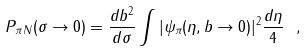<formula> <loc_0><loc_0><loc_500><loc_500>P _ { \pi N } ( \sigma \rightarrow 0 ) = \frac { d b ^ { 2 } } { d \sigma } \int | \psi _ { \pi } ( \eta , b \rightarrow 0 ) | ^ { 2 } \frac { d \eta } { 4 } \ ,</formula> 